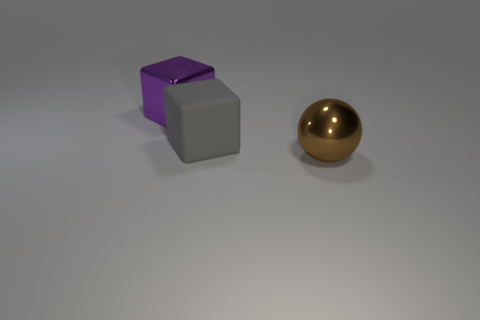Is there anything else that has the same material as the large gray block?
Provide a short and direct response. No. What is the material of the large object on the left side of the large matte thing?
Give a very brief answer. Metal. Does the ball have the same size as the gray object?
Offer a terse response. Yes. Is the number of large cubes that are right of the purple thing greater than the number of big brown metal cylinders?
Your answer should be very brief. Yes. What size is the brown ball that is the same material as the purple object?
Your response must be concise. Large. There is a brown object; are there any metallic objects to the left of it?
Give a very brief answer. Yes. Is the shape of the matte thing the same as the big brown metal object?
Your answer should be compact. No. There is a metal thing that is left of the big metallic object to the right of the large block in front of the purple metallic block; how big is it?
Your answer should be compact. Large. What is the big gray thing made of?
Give a very brief answer. Rubber. There is a gray rubber thing; is its shape the same as the big shiny thing that is on the left side of the rubber cube?
Keep it short and to the point. Yes. 